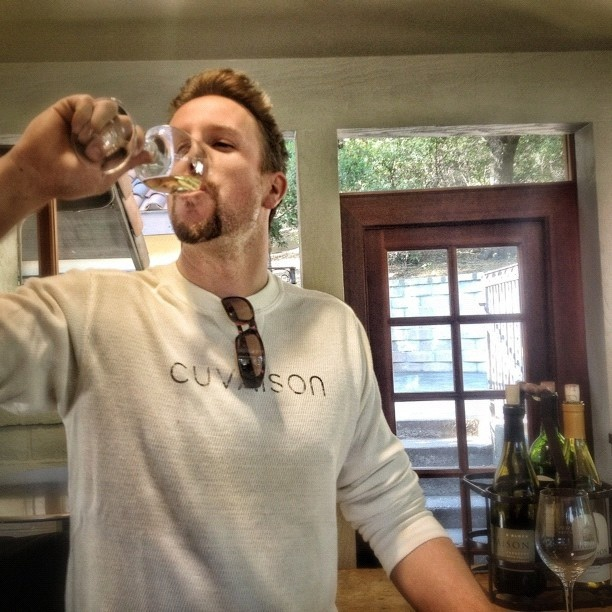Describe the objects in this image and their specific colors. I can see people in olive, darkgray, gray, and tan tones, bottle in olive, black, and gray tones, wine glass in olive, gray, brown, tan, and maroon tones, wine glass in olive, black, and gray tones, and bottle in olive, black, and gray tones in this image. 